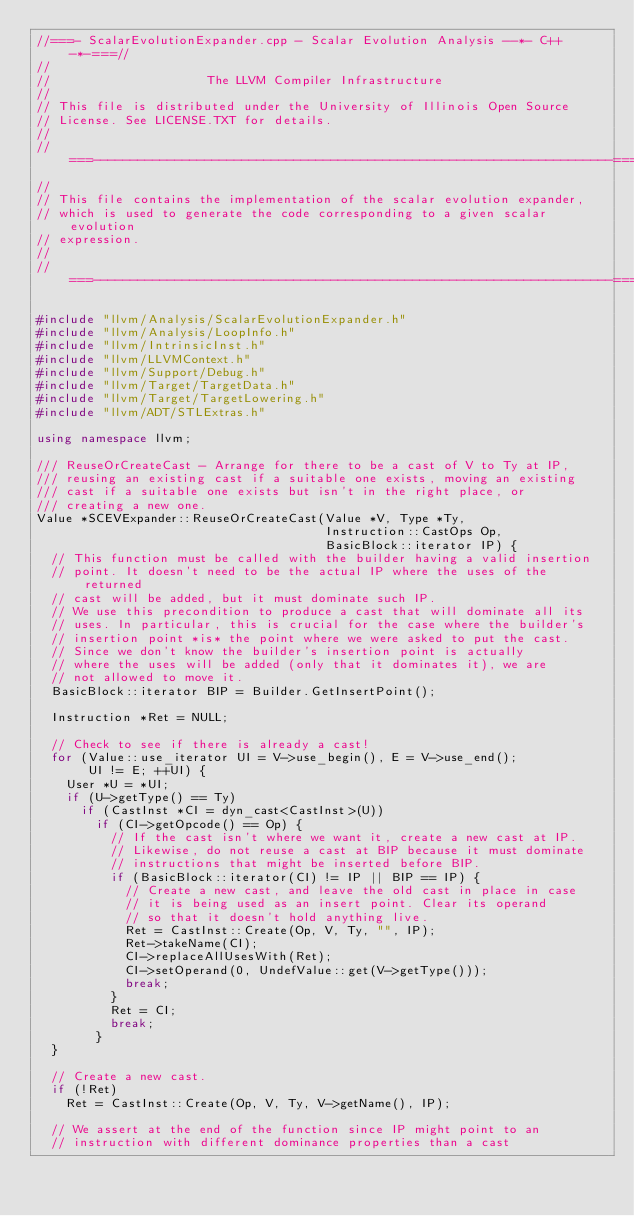<code> <loc_0><loc_0><loc_500><loc_500><_C++_>//===- ScalarEvolutionExpander.cpp - Scalar Evolution Analysis --*- C++ -*-===//
//
//                     The LLVM Compiler Infrastructure
//
// This file is distributed under the University of Illinois Open Source
// License. See LICENSE.TXT for details.
//
//===----------------------------------------------------------------------===//
//
// This file contains the implementation of the scalar evolution expander,
// which is used to generate the code corresponding to a given scalar evolution
// expression.
//
//===----------------------------------------------------------------------===//

#include "llvm/Analysis/ScalarEvolutionExpander.h"
#include "llvm/Analysis/LoopInfo.h"
#include "llvm/IntrinsicInst.h"
#include "llvm/LLVMContext.h"
#include "llvm/Support/Debug.h"
#include "llvm/Target/TargetData.h"
#include "llvm/Target/TargetLowering.h"
#include "llvm/ADT/STLExtras.h"

using namespace llvm;

/// ReuseOrCreateCast - Arrange for there to be a cast of V to Ty at IP,
/// reusing an existing cast if a suitable one exists, moving an existing
/// cast if a suitable one exists but isn't in the right place, or
/// creating a new one.
Value *SCEVExpander::ReuseOrCreateCast(Value *V, Type *Ty,
                                       Instruction::CastOps Op,
                                       BasicBlock::iterator IP) {
  // This function must be called with the builder having a valid insertion
  // point. It doesn't need to be the actual IP where the uses of the returned
  // cast will be added, but it must dominate such IP.
  // We use this precondition to produce a cast that will dominate all its
  // uses. In particular, this is crucial for the case where the builder's
  // insertion point *is* the point where we were asked to put the cast.
  // Since we don't know the builder's insertion point is actually
  // where the uses will be added (only that it dominates it), we are
  // not allowed to move it.
  BasicBlock::iterator BIP = Builder.GetInsertPoint();

  Instruction *Ret = NULL;

  // Check to see if there is already a cast!
  for (Value::use_iterator UI = V->use_begin(), E = V->use_end();
       UI != E; ++UI) {
    User *U = *UI;
    if (U->getType() == Ty)
      if (CastInst *CI = dyn_cast<CastInst>(U))
        if (CI->getOpcode() == Op) {
          // If the cast isn't where we want it, create a new cast at IP.
          // Likewise, do not reuse a cast at BIP because it must dominate
          // instructions that might be inserted before BIP.
          if (BasicBlock::iterator(CI) != IP || BIP == IP) {
            // Create a new cast, and leave the old cast in place in case
            // it is being used as an insert point. Clear its operand
            // so that it doesn't hold anything live.
            Ret = CastInst::Create(Op, V, Ty, "", IP);
            Ret->takeName(CI);
            CI->replaceAllUsesWith(Ret);
            CI->setOperand(0, UndefValue::get(V->getType()));
            break;
          }
          Ret = CI;
          break;
        }
  }

  // Create a new cast.
  if (!Ret)
    Ret = CastInst::Create(Op, V, Ty, V->getName(), IP);

  // We assert at the end of the function since IP might point to an
  // instruction with different dominance properties than a cast</code> 